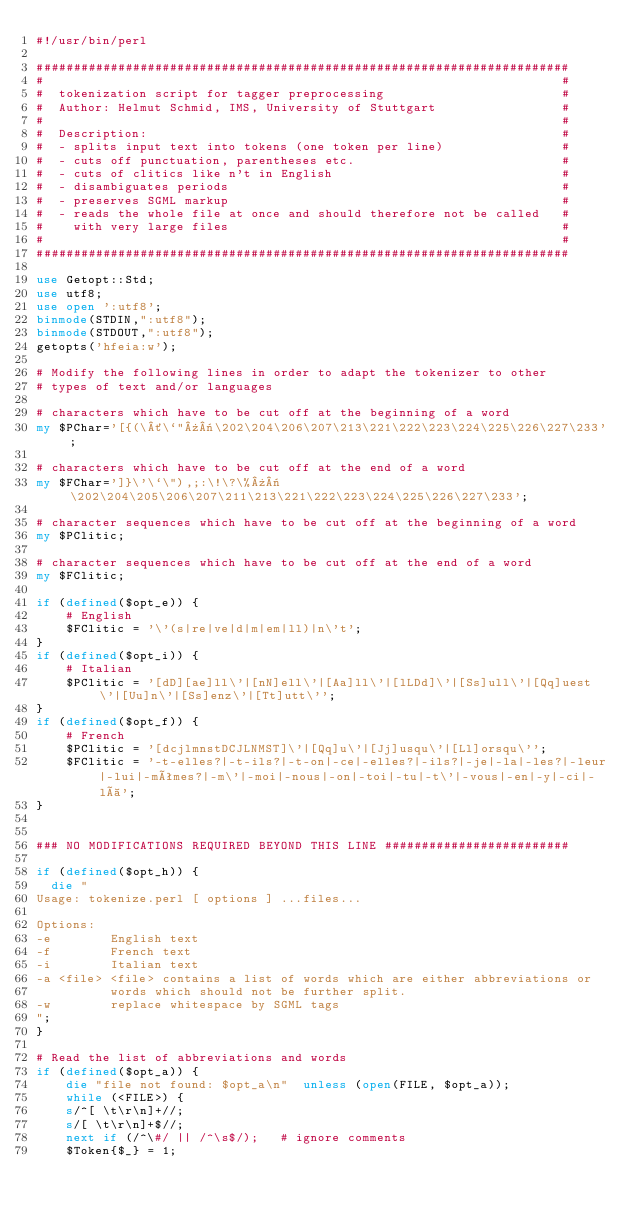<code> <loc_0><loc_0><loc_500><loc_500><_Perl_>#!/usr/bin/perl

########################################################################
#                                                                      #
#  tokenization script for tagger preprocessing                        #
#  Author: Helmut Schmid, IMS, University of Stuttgart                 #
#                                                                      #
#  Description:                                                        #
#  - splits input text into tokens (one token per line)                #
#  - cuts off punctuation, parentheses etc.                            #
#  - cuts of clitics like n't in English                               #
#  - disambiguates periods                                             #
#  - preserves SGML markup                                             #
#  - reads the whole file at once and should therefore not be called   #
#    with very large files                                             #
#                                                                      #
########################################################################

use Getopt::Std;
use utf8;
use open ':utf8';
binmode(STDIN,":utf8");
binmode(STDOUT,":utf8");
getopts('hfeia:w');

# Modify the following lines in order to adapt the tokenizer to other
# types of text and/or languages

# characters which have to be cut off at the beginning of a word
my $PChar='[{(\´\`"»«\202\204\206\207\213\221\222\223\224\225\226\227\233';

# characters which have to be cut off at the end of a word
my $FChar=']}\'\`\"),;:\!\?\%»«\202\204\205\206\207\211\213\221\222\223\224\225\226\227\233';

# character sequences which have to be cut off at the beginning of a word
my $PClitic;

# character sequences which have to be cut off at the end of a word
my $FClitic;

if (defined($opt_e)) {
    # English
    $FClitic = '\'(s|re|ve|d|m|em|ll)|n\'t';
}
if (defined($opt_i)) {
    # Italian
    $PClitic = '[dD][ae]ll\'|[nN]ell\'|[Aa]ll\'|[lLDd]\'|[Ss]ull\'|[Qq]uest\'|[Uu]n\'|[Ss]enz\'|[Tt]utt\'';
}
if (defined($opt_f)) {
    # French
    $PClitic = '[dcjlmnstDCJLNMST]\'|[Qq]u\'|[Jj]usqu\'|[Ll]orsqu\'';
    $FClitic = '-t-elles?|-t-ils?|-t-on|-ce|-elles?|-ils?|-je|-la|-les?|-leur|-lui|-mêmes?|-m\'|-moi|-nous|-on|-toi|-tu|-t\'|-vous|-en|-y|-ci|-là';
}


### NO MODIFICATIONS REQUIRED BEYOND THIS LINE #########################

if (defined($opt_h)) {
  die "
Usage: tokenize.perl [ options ] ...files...

Options:
-e        English text 
-f        French text
-i        Italian text
-a <file> <file> contains a list of words which are either abbreviations or
          words which should not be further split.
-w        replace whitespace by SGML tags
";
}

# Read the list of abbreviations and words
if (defined($opt_a)) {
    die "file not found: $opt_a\n"  unless (open(FILE, $opt_a));
    while (<FILE>) {
	s/^[ \t\r\n]+//;
	s/[ \t\r\n]+$//;
	next if (/^\#/ || /^\s$/);   # ignore comments
	$Token{$_} = 1;</code> 